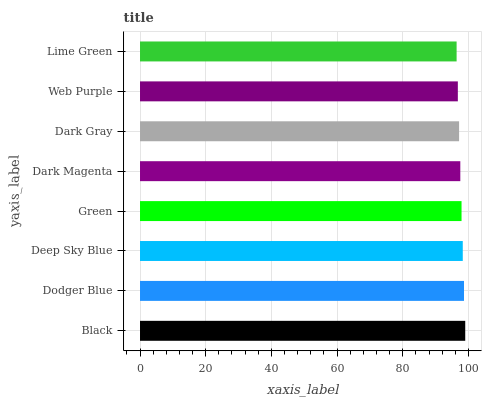Is Lime Green the minimum?
Answer yes or no. Yes. Is Black the maximum?
Answer yes or no. Yes. Is Dodger Blue the minimum?
Answer yes or no. No. Is Dodger Blue the maximum?
Answer yes or no. No. Is Black greater than Dodger Blue?
Answer yes or no. Yes. Is Dodger Blue less than Black?
Answer yes or no. Yes. Is Dodger Blue greater than Black?
Answer yes or no. No. Is Black less than Dodger Blue?
Answer yes or no. No. Is Green the high median?
Answer yes or no. Yes. Is Dark Magenta the low median?
Answer yes or no. Yes. Is Lime Green the high median?
Answer yes or no. No. Is Black the low median?
Answer yes or no. No. 